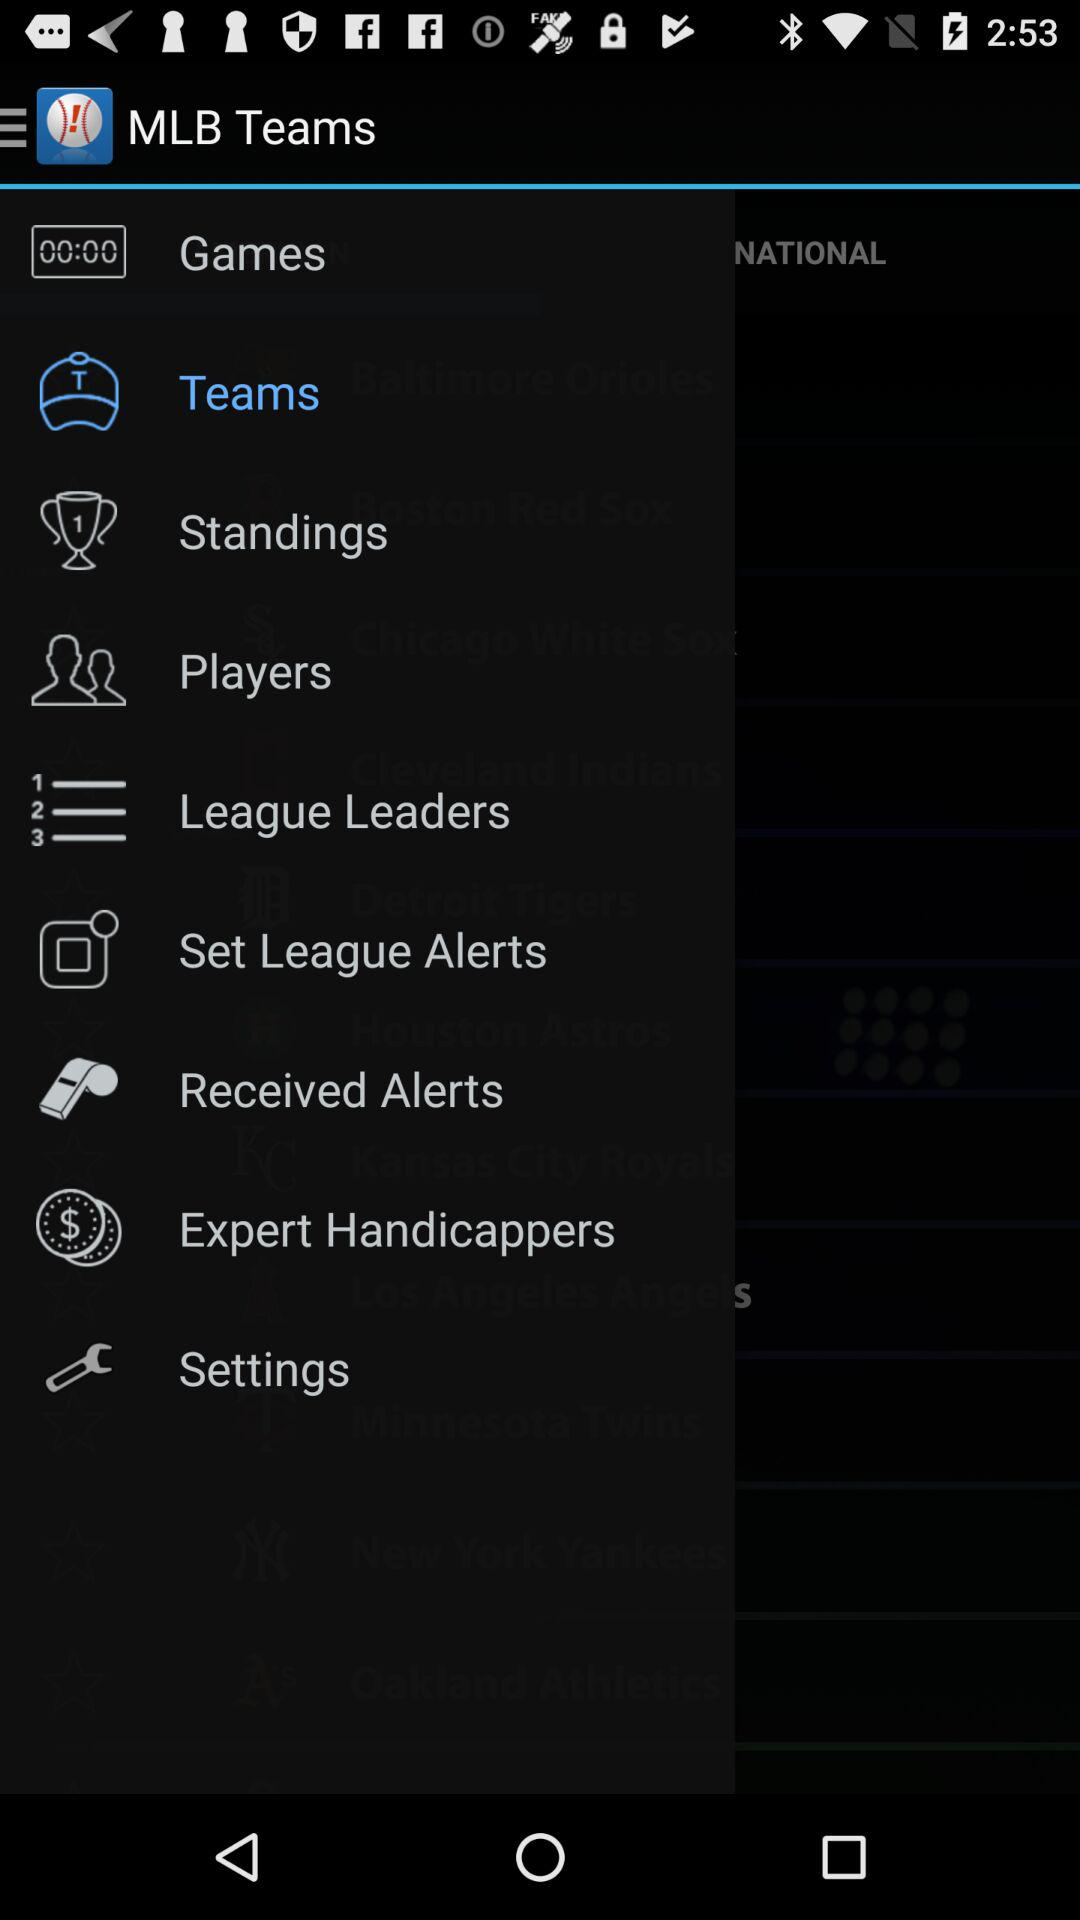What is the selected option? The selected option is "Teams". 